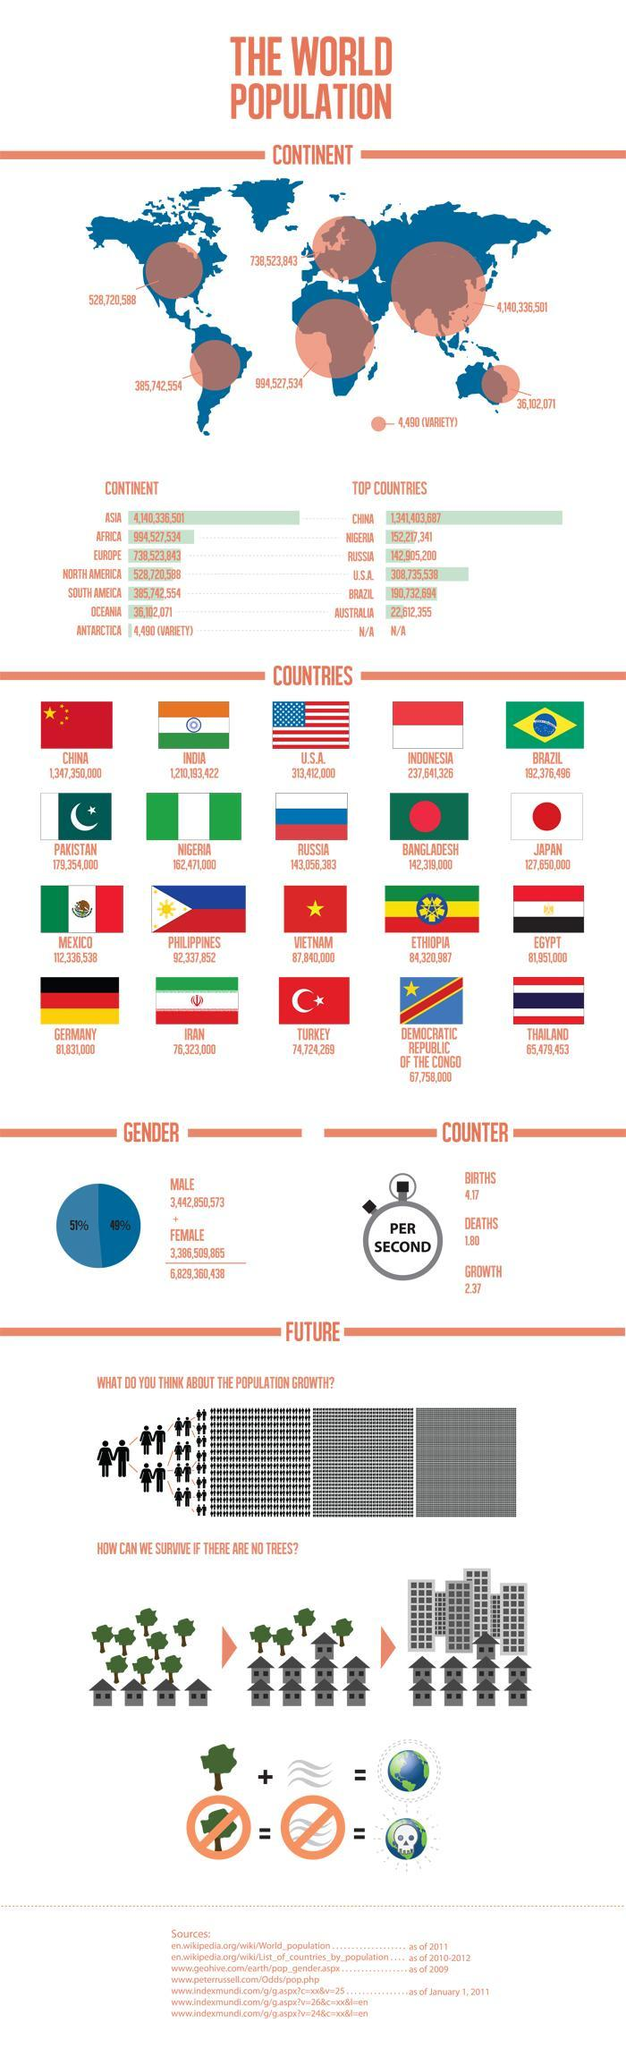What is the population in Russia?
Answer the question with a short phrase. 143,056,383 How many countries have red color in their flag? 16 How many countries have no red color in their flag? 4 What is the population in Thailand? 65,479,453 What is the population in Indonesia? 237,641,326 What is the number of births and deaths per second, taken together? 5.97 What is the population in Iran? 76,323,000 